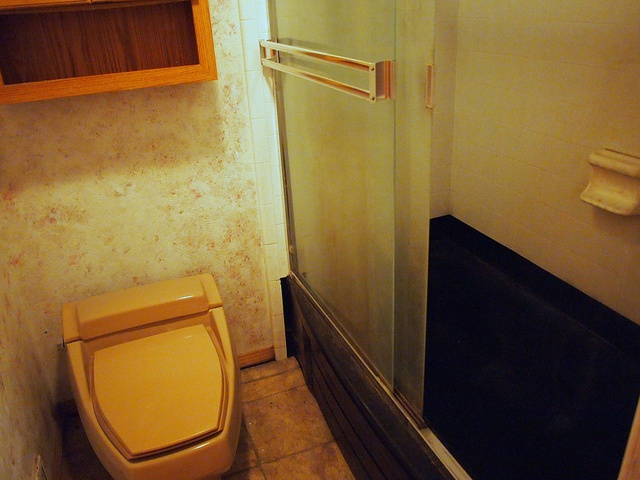Describe the objects in this image and their specific colors. I can see a toilet in brown, red, orange, and maroon tones in this image. 